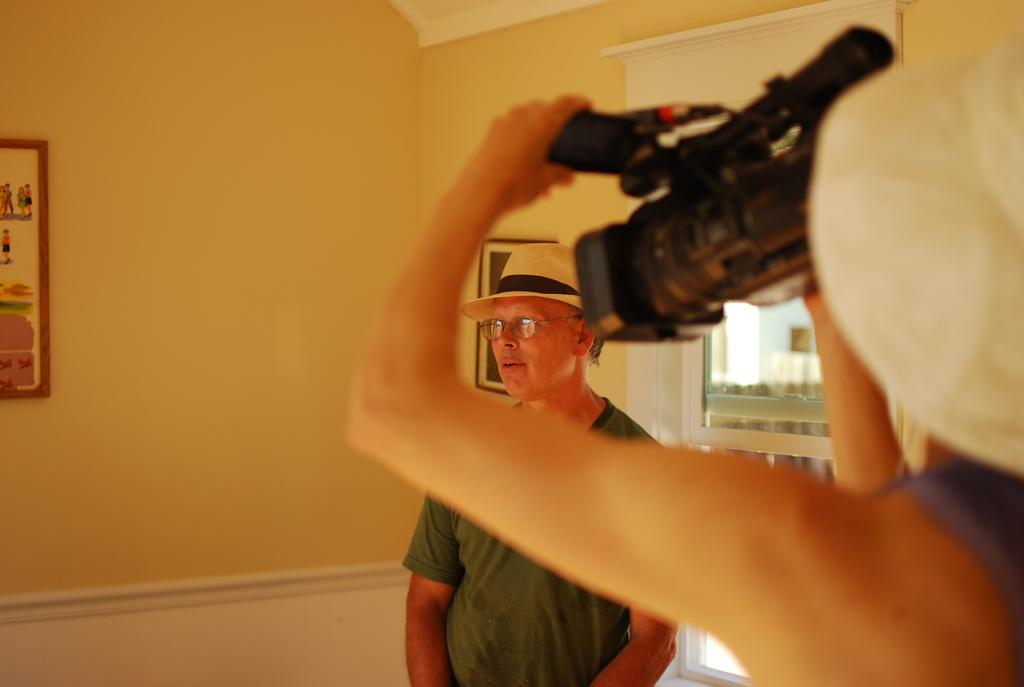What is the main subject in the image? There is a man standing in the image. What can be seen in the background of the image? There is a window in the image. What is hanging on the wall in the image? There are photo frames on a wall in the image. What is the person in the foreground of the image holding? A person is holding a camera in the foreground of the image. What type of vegetable is being used as a prop in the image? There is no vegetable present in the image. What degree does the man in the image have? The image does not provide information about the man's degree. 